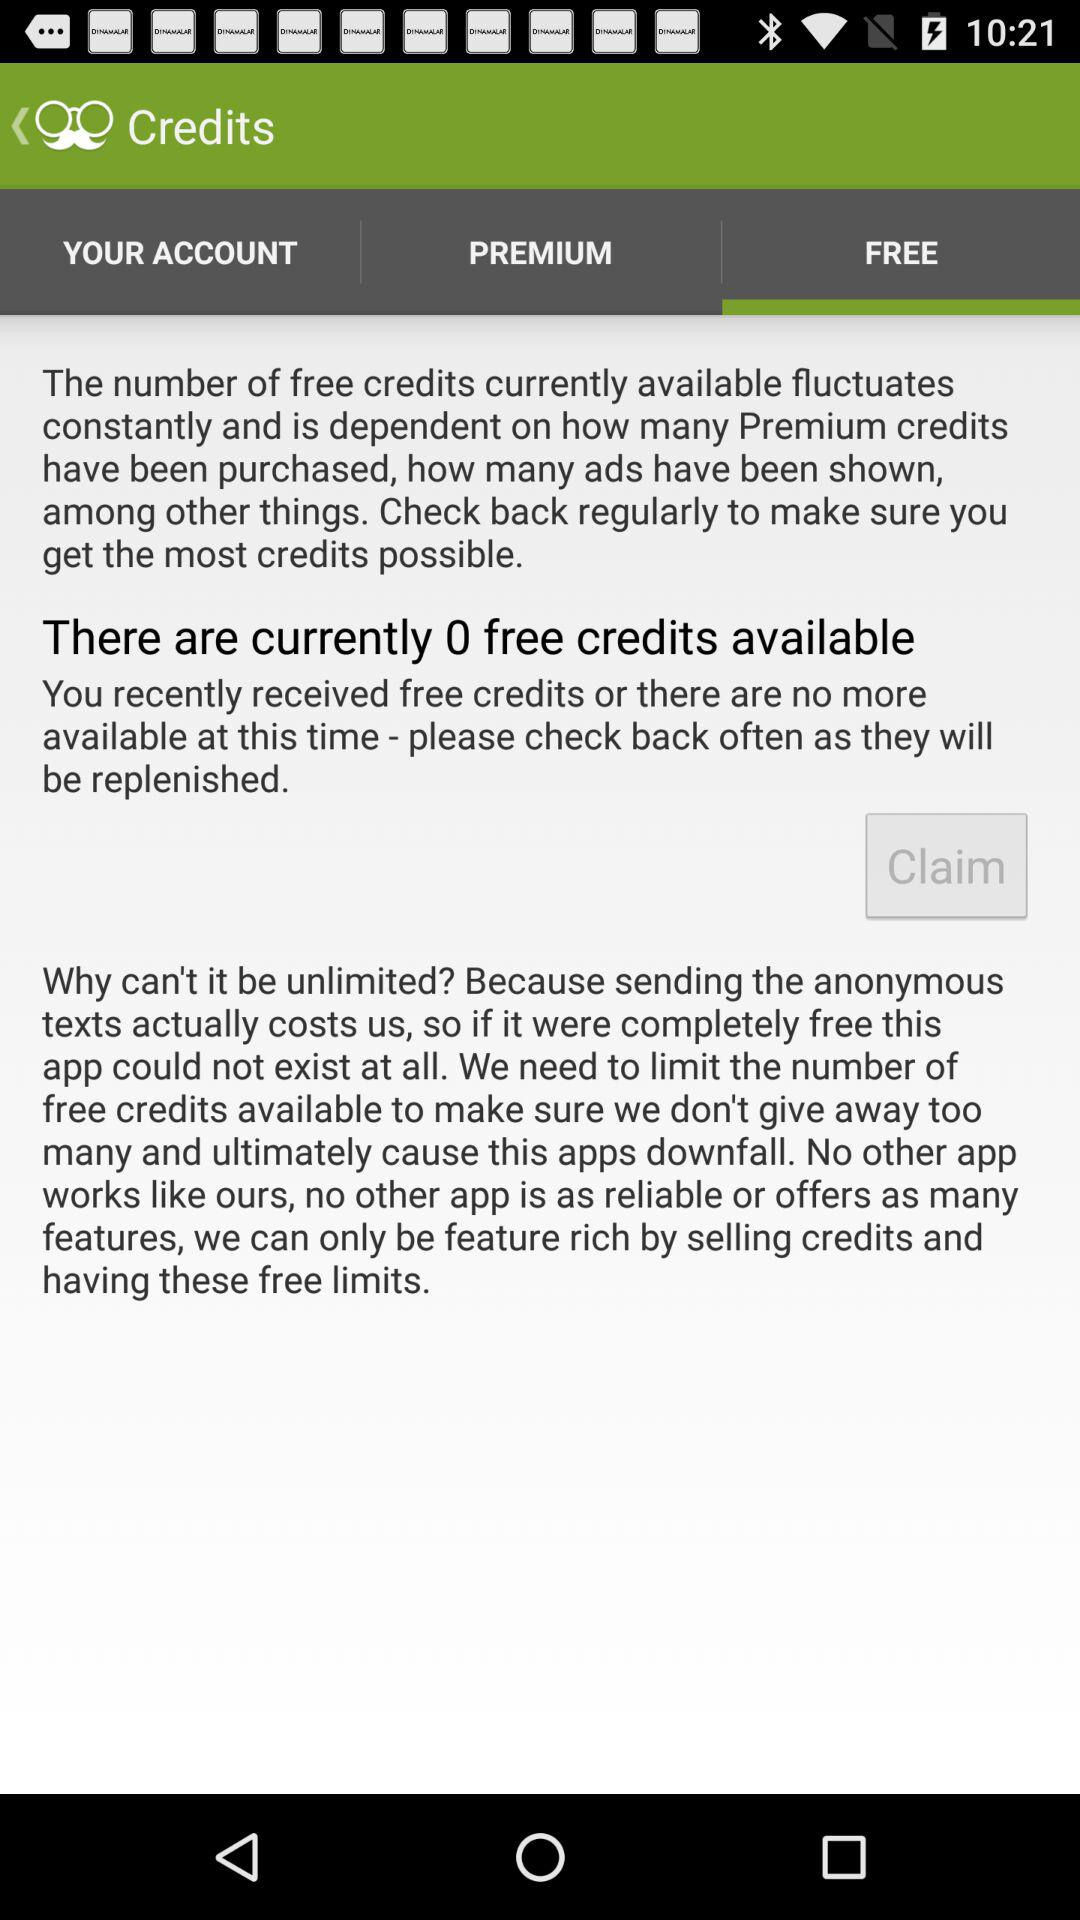How many credits are currently available? There are currently 0 free credits available. 